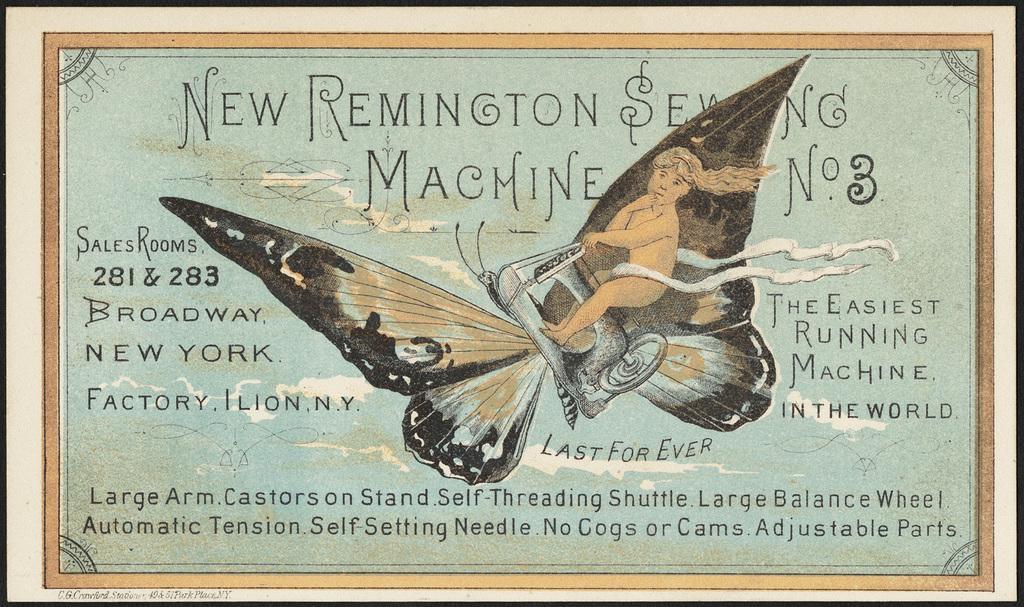Describe this image in one or two sentences. In this picture there is a poster. In the center there is a picture of a butterfly flying. On it's back there is a person sitting on the sewing machine. Around the picture there is the text. 